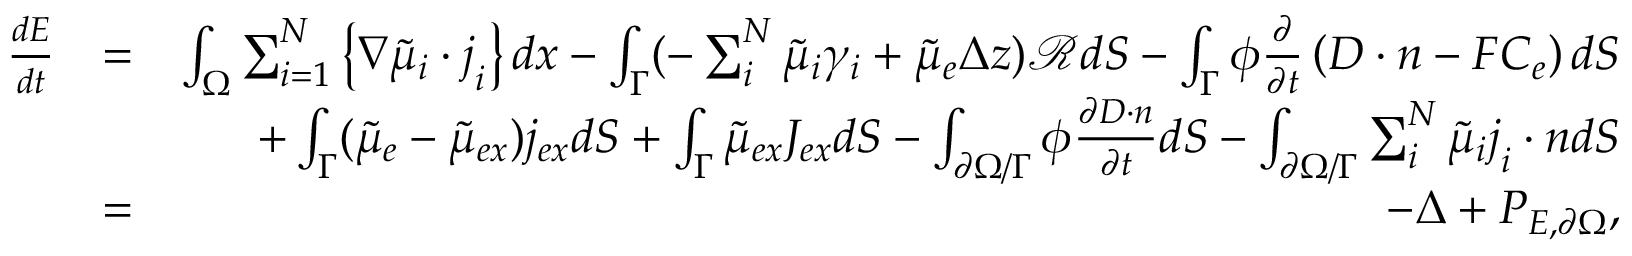<formula> <loc_0><loc_0><loc_500><loc_500>\begin{array} { r l r } { \frac { d E } { d t } } & { = } & { \int _ { \Omega } \sum _ { i = 1 } ^ { N } \left \{ \nabla \tilde { \mu } _ { i } \cdot j _ { i } \right \} d x - \int _ { \Gamma } ( - \sum _ { i } ^ { N } \tilde { \mu } _ { i } \gamma _ { i } + \tilde { \mu } _ { e } \Delta z ) \mathcal { R } d S - \int _ { \Gamma } \phi \frac { \partial } { \partial t } \left ( D \cdot n - F C _ { e } \right ) d S } \\ & { + \int _ { \Gamma } ( \tilde { \mu } _ { e } - \tilde { \mu } _ { e x } ) j _ { e x } d S + \int _ { \Gamma } \tilde { \mu } _ { e x } J _ { e x } d S - \int _ { \partial \Omega / \Gamma } \phi \frac { \partial D \cdot n } { \partial t } d S - \int _ { \partial \Omega / \Gamma } \sum _ { i } ^ { N } \tilde { \mu } _ { i } j _ { i } \cdot n d S } \\ & { = } & { - \Delta + P _ { E , \partial \Omega } , } \end{array}</formula> 